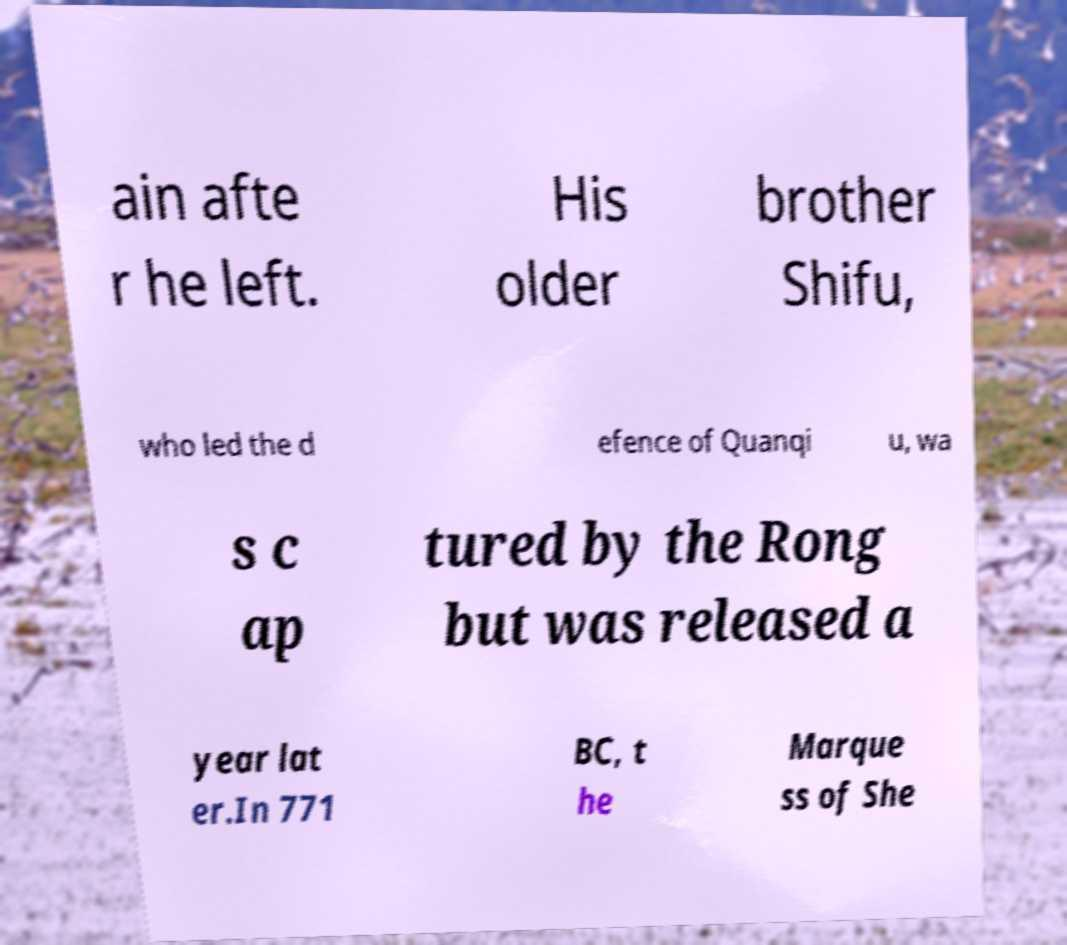Could you assist in decoding the text presented in this image and type it out clearly? ain afte r he left. His older brother Shifu, who led the d efence of Quanqi u, wa s c ap tured by the Rong but was released a year lat er.In 771 BC, t he Marque ss of She 